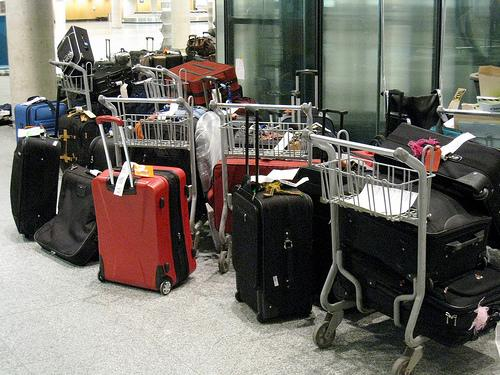Briefly describe the floor in the image. The floor has gray tiles and small lines. What kind of objects are on the luggage cart and what are their colors? There are several suitcases on the cart, which are black, and boxes behind them. List the types and colors of rolling luggage bags in the image. There are three rolling luggage bags: red, black, and blue. 